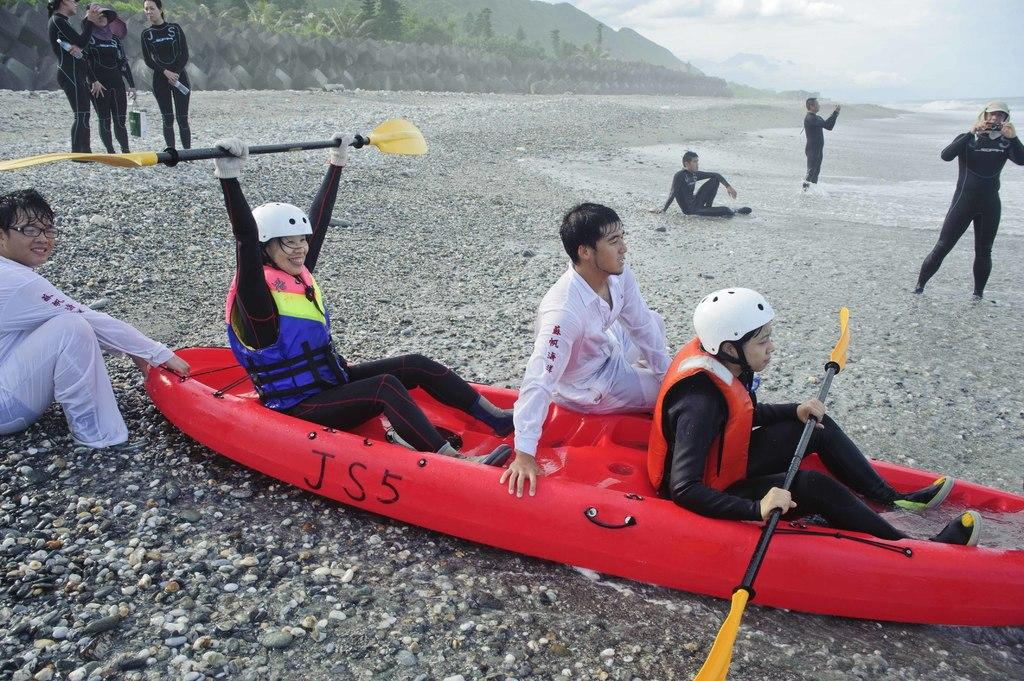Where was the image taken? The image is clicked outside. What is the main subject in the middle of the image? There is a small boat in the middle of the image. Are there any people visible in the image? Yes, there are people in the image. What type of location does the image appear to be taken at? The image appears to be taken at a beach. How does the image provide comfort to the people in the boat? The image itself does not provide comfort to the people in the boat; it is a static representation of the scene. 